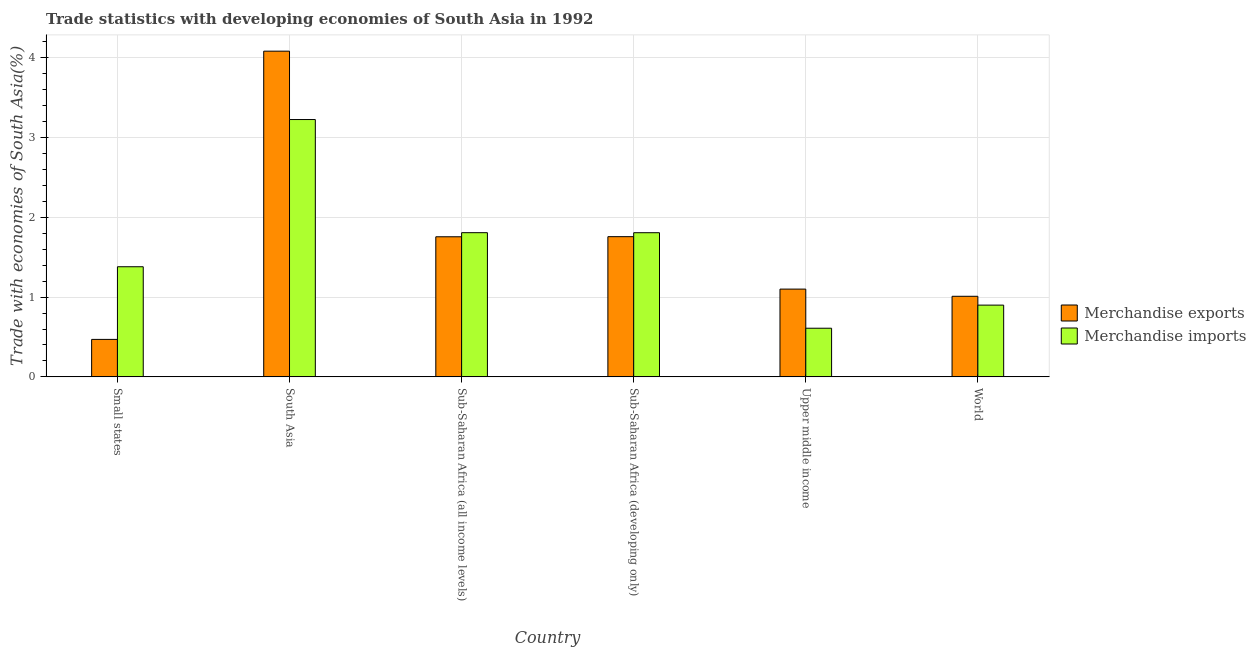How many different coloured bars are there?
Offer a terse response. 2. Are the number of bars per tick equal to the number of legend labels?
Your answer should be very brief. Yes. How many bars are there on the 6th tick from the right?
Provide a succinct answer. 2. What is the label of the 4th group of bars from the left?
Offer a terse response. Sub-Saharan Africa (developing only). In how many cases, is the number of bars for a given country not equal to the number of legend labels?
Ensure brevity in your answer.  0. What is the merchandise exports in South Asia?
Offer a very short reply. 4.08. Across all countries, what is the maximum merchandise imports?
Keep it short and to the point. 3.23. Across all countries, what is the minimum merchandise exports?
Make the answer very short. 0.47. In which country was the merchandise exports minimum?
Offer a very short reply. Small states. What is the total merchandise imports in the graph?
Offer a terse response. 9.73. What is the difference between the merchandise exports in Small states and that in South Asia?
Offer a terse response. -3.61. What is the difference between the merchandise imports in Sub-Saharan Africa (developing only) and the merchandise exports in Upper middle income?
Offer a terse response. 0.71. What is the average merchandise imports per country?
Ensure brevity in your answer.  1.62. What is the difference between the merchandise imports and merchandise exports in Sub-Saharan Africa (all income levels)?
Make the answer very short. 0.05. In how many countries, is the merchandise imports greater than 2.8 %?
Give a very brief answer. 1. What is the ratio of the merchandise imports in Sub-Saharan Africa (all income levels) to that in Upper middle income?
Your response must be concise. 2.96. What is the difference between the highest and the second highest merchandise exports?
Your answer should be compact. 2.33. What is the difference between the highest and the lowest merchandise exports?
Make the answer very short. 3.61. What is the difference between two consecutive major ticks on the Y-axis?
Offer a very short reply. 1. Does the graph contain any zero values?
Keep it short and to the point. No. Does the graph contain grids?
Your answer should be very brief. Yes. Where does the legend appear in the graph?
Give a very brief answer. Center right. How many legend labels are there?
Your response must be concise. 2. How are the legend labels stacked?
Offer a terse response. Vertical. What is the title of the graph?
Give a very brief answer. Trade statistics with developing economies of South Asia in 1992. What is the label or title of the Y-axis?
Provide a succinct answer. Trade with economies of South Asia(%). What is the Trade with economies of South Asia(%) of Merchandise exports in Small states?
Offer a terse response. 0.47. What is the Trade with economies of South Asia(%) in Merchandise imports in Small states?
Give a very brief answer. 1.38. What is the Trade with economies of South Asia(%) of Merchandise exports in South Asia?
Offer a very short reply. 4.08. What is the Trade with economies of South Asia(%) in Merchandise imports in South Asia?
Your response must be concise. 3.23. What is the Trade with economies of South Asia(%) of Merchandise exports in Sub-Saharan Africa (all income levels)?
Your answer should be compact. 1.76. What is the Trade with economies of South Asia(%) in Merchandise imports in Sub-Saharan Africa (all income levels)?
Give a very brief answer. 1.81. What is the Trade with economies of South Asia(%) of Merchandise exports in Sub-Saharan Africa (developing only)?
Your response must be concise. 1.76. What is the Trade with economies of South Asia(%) in Merchandise imports in Sub-Saharan Africa (developing only)?
Ensure brevity in your answer.  1.81. What is the Trade with economies of South Asia(%) of Merchandise exports in Upper middle income?
Ensure brevity in your answer.  1.1. What is the Trade with economies of South Asia(%) in Merchandise imports in Upper middle income?
Provide a short and direct response. 0.61. What is the Trade with economies of South Asia(%) in Merchandise exports in World?
Your answer should be compact. 1.01. What is the Trade with economies of South Asia(%) of Merchandise imports in World?
Ensure brevity in your answer.  0.9. Across all countries, what is the maximum Trade with economies of South Asia(%) of Merchandise exports?
Provide a succinct answer. 4.08. Across all countries, what is the maximum Trade with economies of South Asia(%) in Merchandise imports?
Your response must be concise. 3.23. Across all countries, what is the minimum Trade with economies of South Asia(%) of Merchandise exports?
Provide a short and direct response. 0.47. Across all countries, what is the minimum Trade with economies of South Asia(%) of Merchandise imports?
Keep it short and to the point. 0.61. What is the total Trade with economies of South Asia(%) in Merchandise exports in the graph?
Give a very brief answer. 10.18. What is the total Trade with economies of South Asia(%) of Merchandise imports in the graph?
Your answer should be compact. 9.73. What is the difference between the Trade with economies of South Asia(%) in Merchandise exports in Small states and that in South Asia?
Ensure brevity in your answer.  -3.61. What is the difference between the Trade with economies of South Asia(%) of Merchandise imports in Small states and that in South Asia?
Your response must be concise. -1.85. What is the difference between the Trade with economies of South Asia(%) in Merchandise exports in Small states and that in Sub-Saharan Africa (all income levels)?
Provide a succinct answer. -1.29. What is the difference between the Trade with economies of South Asia(%) of Merchandise imports in Small states and that in Sub-Saharan Africa (all income levels)?
Your answer should be compact. -0.43. What is the difference between the Trade with economies of South Asia(%) in Merchandise exports in Small states and that in Sub-Saharan Africa (developing only)?
Offer a very short reply. -1.29. What is the difference between the Trade with economies of South Asia(%) of Merchandise imports in Small states and that in Sub-Saharan Africa (developing only)?
Provide a short and direct response. -0.43. What is the difference between the Trade with economies of South Asia(%) in Merchandise exports in Small states and that in Upper middle income?
Your response must be concise. -0.63. What is the difference between the Trade with economies of South Asia(%) in Merchandise imports in Small states and that in Upper middle income?
Your answer should be very brief. 0.77. What is the difference between the Trade with economies of South Asia(%) in Merchandise exports in Small states and that in World?
Provide a short and direct response. -0.54. What is the difference between the Trade with economies of South Asia(%) in Merchandise imports in Small states and that in World?
Provide a succinct answer. 0.48. What is the difference between the Trade with economies of South Asia(%) of Merchandise exports in South Asia and that in Sub-Saharan Africa (all income levels)?
Provide a succinct answer. 2.33. What is the difference between the Trade with economies of South Asia(%) of Merchandise imports in South Asia and that in Sub-Saharan Africa (all income levels)?
Ensure brevity in your answer.  1.42. What is the difference between the Trade with economies of South Asia(%) in Merchandise exports in South Asia and that in Sub-Saharan Africa (developing only)?
Keep it short and to the point. 2.33. What is the difference between the Trade with economies of South Asia(%) of Merchandise imports in South Asia and that in Sub-Saharan Africa (developing only)?
Provide a short and direct response. 1.42. What is the difference between the Trade with economies of South Asia(%) of Merchandise exports in South Asia and that in Upper middle income?
Ensure brevity in your answer.  2.98. What is the difference between the Trade with economies of South Asia(%) in Merchandise imports in South Asia and that in Upper middle income?
Ensure brevity in your answer.  2.62. What is the difference between the Trade with economies of South Asia(%) in Merchandise exports in South Asia and that in World?
Provide a succinct answer. 3.07. What is the difference between the Trade with economies of South Asia(%) in Merchandise imports in South Asia and that in World?
Give a very brief answer. 2.33. What is the difference between the Trade with economies of South Asia(%) of Merchandise exports in Sub-Saharan Africa (all income levels) and that in Sub-Saharan Africa (developing only)?
Offer a very short reply. -0. What is the difference between the Trade with economies of South Asia(%) of Merchandise imports in Sub-Saharan Africa (all income levels) and that in Sub-Saharan Africa (developing only)?
Your answer should be very brief. 0. What is the difference between the Trade with economies of South Asia(%) in Merchandise exports in Sub-Saharan Africa (all income levels) and that in Upper middle income?
Keep it short and to the point. 0.66. What is the difference between the Trade with economies of South Asia(%) of Merchandise imports in Sub-Saharan Africa (all income levels) and that in Upper middle income?
Offer a terse response. 1.2. What is the difference between the Trade with economies of South Asia(%) of Merchandise exports in Sub-Saharan Africa (all income levels) and that in World?
Keep it short and to the point. 0.75. What is the difference between the Trade with economies of South Asia(%) in Merchandise imports in Sub-Saharan Africa (all income levels) and that in World?
Your response must be concise. 0.91. What is the difference between the Trade with economies of South Asia(%) of Merchandise exports in Sub-Saharan Africa (developing only) and that in Upper middle income?
Keep it short and to the point. 0.66. What is the difference between the Trade with economies of South Asia(%) of Merchandise imports in Sub-Saharan Africa (developing only) and that in Upper middle income?
Provide a succinct answer. 1.2. What is the difference between the Trade with economies of South Asia(%) in Merchandise exports in Sub-Saharan Africa (developing only) and that in World?
Provide a short and direct response. 0.75. What is the difference between the Trade with economies of South Asia(%) in Merchandise imports in Sub-Saharan Africa (developing only) and that in World?
Your answer should be compact. 0.91. What is the difference between the Trade with economies of South Asia(%) in Merchandise exports in Upper middle income and that in World?
Ensure brevity in your answer.  0.09. What is the difference between the Trade with economies of South Asia(%) in Merchandise imports in Upper middle income and that in World?
Your response must be concise. -0.29. What is the difference between the Trade with economies of South Asia(%) in Merchandise exports in Small states and the Trade with economies of South Asia(%) in Merchandise imports in South Asia?
Your response must be concise. -2.76. What is the difference between the Trade with economies of South Asia(%) in Merchandise exports in Small states and the Trade with economies of South Asia(%) in Merchandise imports in Sub-Saharan Africa (all income levels)?
Offer a very short reply. -1.34. What is the difference between the Trade with economies of South Asia(%) in Merchandise exports in Small states and the Trade with economies of South Asia(%) in Merchandise imports in Sub-Saharan Africa (developing only)?
Make the answer very short. -1.34. What is the difference between the Trade with economies of South Asia(%) in Merchandise exports in Small states and the Trade with economies of South Asia(%) in Merchandise imports in Upper middle income?
Your answer should be compact. -0.14. What is the difference between the Trade with economies of South Asia(%) of Merchandise exports in Small states and the Trade with economies of South Asia(%) of Merchandise imports in World?
Your answer should be very brief. -0.43. What is the difference between the Trade with economies of South Asia(%) in Merchandise exports in South Asia and the Trade with economies of South Asia(%) in Merchandise imports in Sub-Saharan Africa (all income levels)?
Your answer should be compact. 2.28. What is the difference between the Trade with economies of South Asia(%) in Merchandise exports in South Asia and the Trade with economies of South Asia(%) in Merchandise imports in Sub-Saharan Africa (developing only)?
Provide a succinct answer. 2.28. What is the difference between the Trade with economies of South Asia(%) of Merchandise exports in South Asia and the Trade with economies of South Asia(%) of Merchandise imports in Upper middle income?
Make the answer very short. 3.47. What is the difference between the Trade with economies of South Asia(%) in Merchandise exports in South Asia and the Trade with economies of South Asia(%) in Merchandise imports in World?
Offer a terse response. 3.18. What is the difference between the Trade with economies of South Asia(%) in Merchandise exports in Sub-Saharan Africa (all income levels) and the Trade with economies of South Asia(%) in Merchandise imports in Sub-Saharan Africa (developing only)?
Make the answer very short. -0.05. What is the difference between the Trade with economies of South Asia(%) of Merchandise exports in Sub-Saharan Africa (all income levels) and the Trade with economies of South Asia(%) of Merchandise imports in Upper middle income?
Keep it short and to the point. 1.15. What is the difference between the Trade with economies of South Asia(%) of Merchandise exports in Sub-Saharan Africa (all income levels) and the Trade with economies of South Asia(%) of Merchandise imports in World?
Keep it short and to the point. 0.86. What is the difference between the Trade with economies of South Asia(%) in Merchandise exports in Sub-Saharan Africa (developing only) and the Trade with economies of South Asia(%) in Merchandise imports in Upper middle income?
Your answer should be compact. 1.15. What is the difference between the Trade with economies of South Asia(%) of Merchandise exports in Sub-Saharan Africa (developing only) and the Trade with economies of South Asia(%) of Merchandise imports in World?
Offer a terse response. 0.86. What is the difference between the Trade with economies of South Asia(%) in Merchandise exports in Upper middle income and the Trade with economies of South Asia(%) in Merchandise imports in World?
Your response must be concise. 0.2. What is the average Trade with economies of South Asia(%) of Merchandise exports per country?
Keep it short and to the point. 1.7. What is the average Trade with economies of South Asia(%) in Merchandise imports per country?
Your answer should be very brief. 1.62. What is the difference between the Trade with economies of South Asia(%) in Merchandise exports and Trade with economies of South Asia(%) in Merchandise imports in Small states?
Your response must be concise. -0.91. What is the difference between the Trade with economies of South Asia(%) of Merchandise exports and Trade with economies of South Asia(%) of Merchandise imports in South Asia?
Provide a short and direct response. 0.86. What is the difference between the Trade with economies of South Asia(%) in Merchandise exports and Trade with economies of South Asia(%) in Merchandise imports in Sub-Saharan Africa (all income levels)?
Provide a succinct answer. -0.05. What is the difference between the Trade with economies of South Asia(%) of Merchandise exports and Trade with economies of South Asia(%) of Merchandise imports in Sub-Saharan Africa (developing only)?
Offer a very short reply. -0.05. What is the difference between the Trade with economies of South Asia(%) of Merchandise exports and Trade with economies of South Asia(%) of Merchandise imports in Upper middle income?
Provide a short and direct response. 0.49. What is the difference between the Trade with economies of South Asia(%) of Merchandise exports and Trade with economies of South Asia(%) of Merchandise imports in World?
Your answer should be compact. 0.11. What is the ratio of the Trade with economies of South Asia(%) of Merchandise exports in Small states to that in South Asia?
Offer a terse response. 0.12. What is the ratio of the Trade with economies of South Asia(%) of Merchandise imports in Small states to that in South Asia?
Provide a succinct answer. 0.43. What is the ratio of the Trade with economies of South Asia(%) in Merchandise exports in Small states to that in Sub-Saharan Africa (all income levels)?
Make the answer very short. 0.27. What is the ratio of the Trade with economies of South Asia(%) in Merchandise imports in Small states to that in Sub-Saharan Africa (all income levels)?
Give a very brief answer. 0.76. What is the ratio of the Trade with economies of South Asia(%) of Merchandise exports in Small states to that in Sub-Saharan Africa (developing only)?
Ensure brevity in your answer.  0.27. What is the ratio of the Trade with economies of South Asia(%) in Merchandise imports in Small states to that in Sub-Saharan Africa (developing only)?
Provide a short and direct response. 0.76. What is the ratio of the Trade with economies of South Asia(%) of Merchandise exports in Small states to that in Upper middle income?
Your answer should be very brief. 0.43. What is the ratio of the Trade with economies of South Asia(%) of Merchandise imports in Small states to that in Upper middle income?
Provide a short and direct response. 2.26. What is the ratio of the Trade with economies of South Asia(%) in Merchandise exports in Small states to that in World?
Offer a very short reply. 0.47. What is the ratio of the Trade with economies of South Asia(%) of Merchandise imports in Small states to that in World?
Your response must be concise. 1.53. What is the ratio of the Trade with economies of South Asia(%) in Merchandise exports in South Asia to that in Sub-Saharan Africa (all income levels)?
Ensure brevity in your answer.  2.33. What is the ratio of the Trade with economies of South Asia(%) of Merchandise imports in South Asia to that in Sub-Saharan Africa (all income levels)?
Give a very brief answer. 1.78. What is the ratio of the Trade with economies of South Asia(%) of Merchandise exports in South Asia to that in Sub-Saharan Africa (developing only)?
Keep it short and to the point. 2.32. What is the ratio of the Trade with economies of South Asia(%) in Merchandise imports in South Asia to that in Sub-Saharan Africa (developing only)?
Give a very brief answer. 1.79. What is the ratio of the Trade with economies of South Asia(%) of Merchandise exports in South Asia to that in Upper middle income?
Give a very brief answer. 3.71. What is the ratio of the Trade with economies of South Asia(%) in Merchandise imports in South Asia to that in Upper middle income?
Give a very brief answer. 5.29. What is the ratio of the Trade with economies of South Asia(%) in Merchandise exports in South Asia to that in World?
Ensure brevity in your answer.  4.04. What is the ratio of the Trade with economies of South Asia(%) of Merchandise imports in South Asia to that in World?
Give a very brief answer. 3.59. What is the ratio of the Trade with economies of South Asia(%) in Merchandise exports in Sub-Saharan Africa (all income levels) to that in Upper middle income?
Provide a succinct answer. 1.6. What is the ratio of the Trade with economies of South Asia(%) of Merchandise imports in Sub-Saharan Africa (all income levels) to that in Upper middle income?
Make the answer very short. 2.96. What is the ratio of the Trade with economies of South Asia(%) of Merchandise exports in Sub-Saharan Africa (all income levels) to that in World?
Keep it short and to the point. 1.74. What is the ratio of the Trade with economies of South Asia(%) in Merchandise imports in Sub-Saharan Africa (all income levels) to that in World?
Provide a succinct answer. 2.01. What is the ratio of the Trade with economies of South Asia(%) of Merchandise exports in Sub-Saharan Africa (developing only) to that in Upper middle income?
Provide a short and direct response. 1.6. What is the ratio of the Trade with economies of South Asia(%) of Merchandise imports in Sub-Saharan Africa (developing only) to that in Upper middle income?
Make the answer very short. 2.96. What is the ratio of the Trade with economies of South Asia(%) of Merchandise exports in Sub-Saharan Africa (developing only) to that in World?
Offer a very short reply. 1.74. What is the ratio of the Trade with economies of South Asia(%) in Merchandise imports in Sub-Saharan Africa (developing only) to that in World?
Keep it short and to the point. 2.01. What is the ratio of the Trade with economies of South Asia(%) of Merchandise exports in Upper middle income to that in World?
Offer a terse response. 1.09. What is the ratio of the Trade with economies of South Asia(%) in Merchandise imports in Upper middle income to that in World?
Offer a terse response. 0.68. What is the difference between the highest and the second highest Trade with economies of South Asia(%) of Merchandise exports?
Offer a terse response. 2.33. What is the difference between the highest and the second highest Trade with economies of South Asia(%) in Merchandise imports?
Offer a very short reply. 1.42. What is the difference between the highest and the lowest Trade with economies of South Asia(%) of Merchandise exports?
Keep it short and to the point. 3.61. What is the difference between the highest and the lowest Trade with economies of South Asia(%) in Merchandise imports?
Provide a succinct answer. 2.62. 